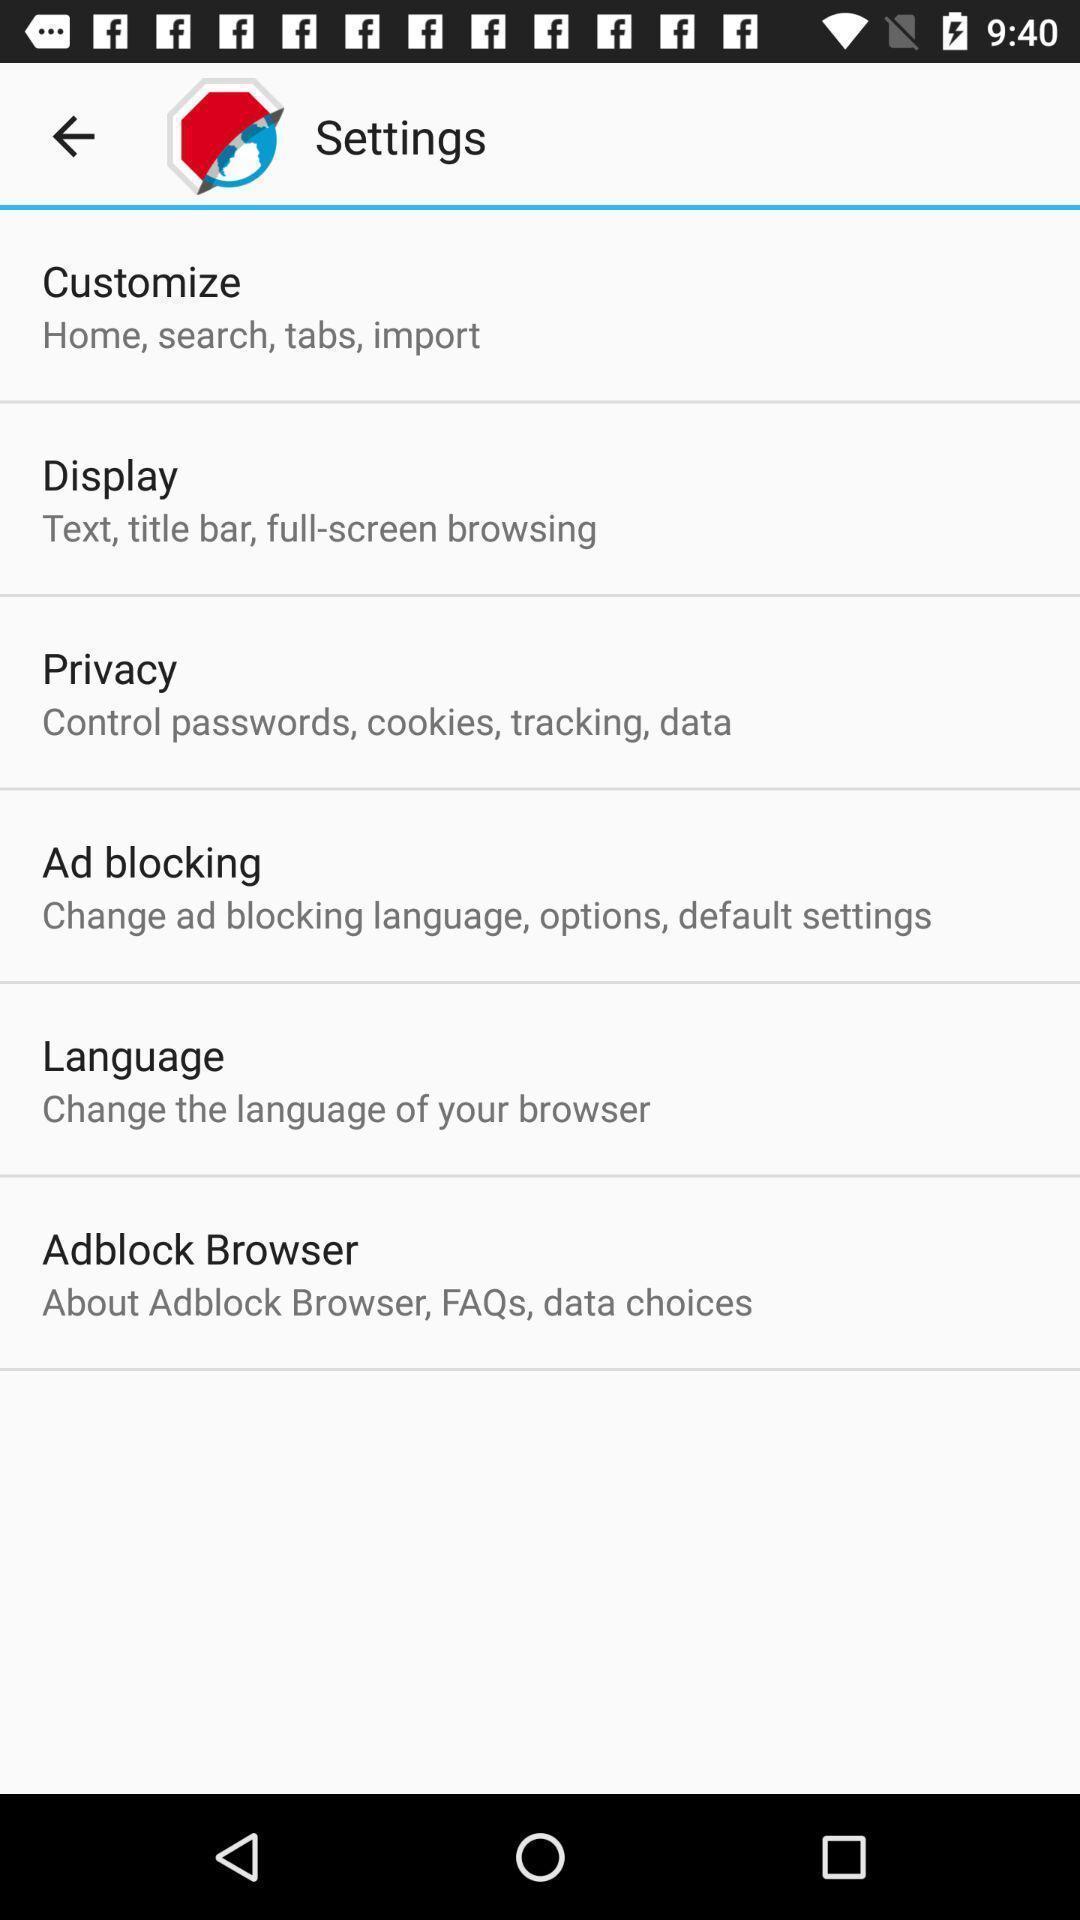Give me a narrative description of this picture. Screen displaying multiple setting options in a browser tool. 